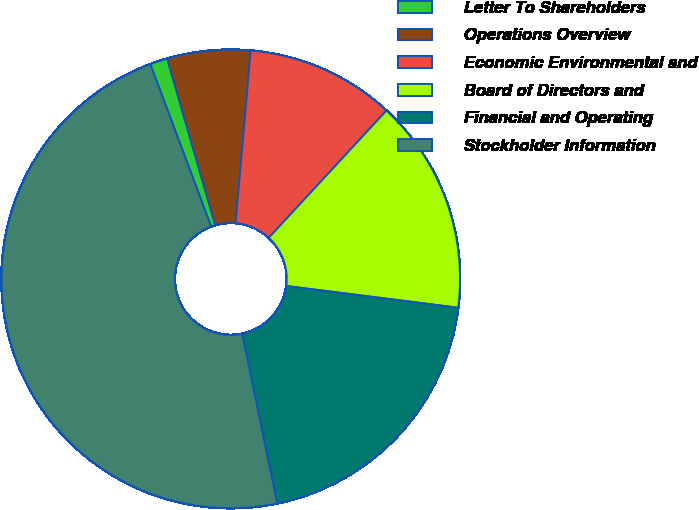Convert chart. <chart><loc_0><loc_0><loc_500><loc_500><pie_chart><fcel>Letter To Shareholders<fcel>Operations Overview<fcel>Economic Environmental and<fcel>Board of Directors and<fcel>Financial and Operating<fcel>Stockholder Information<nl><fcel>1.23%<fcel>5.86%<fcel>10.49%<fcel>15.12%<fcel>19.75%<fcel>47.53%<nl></chart> 